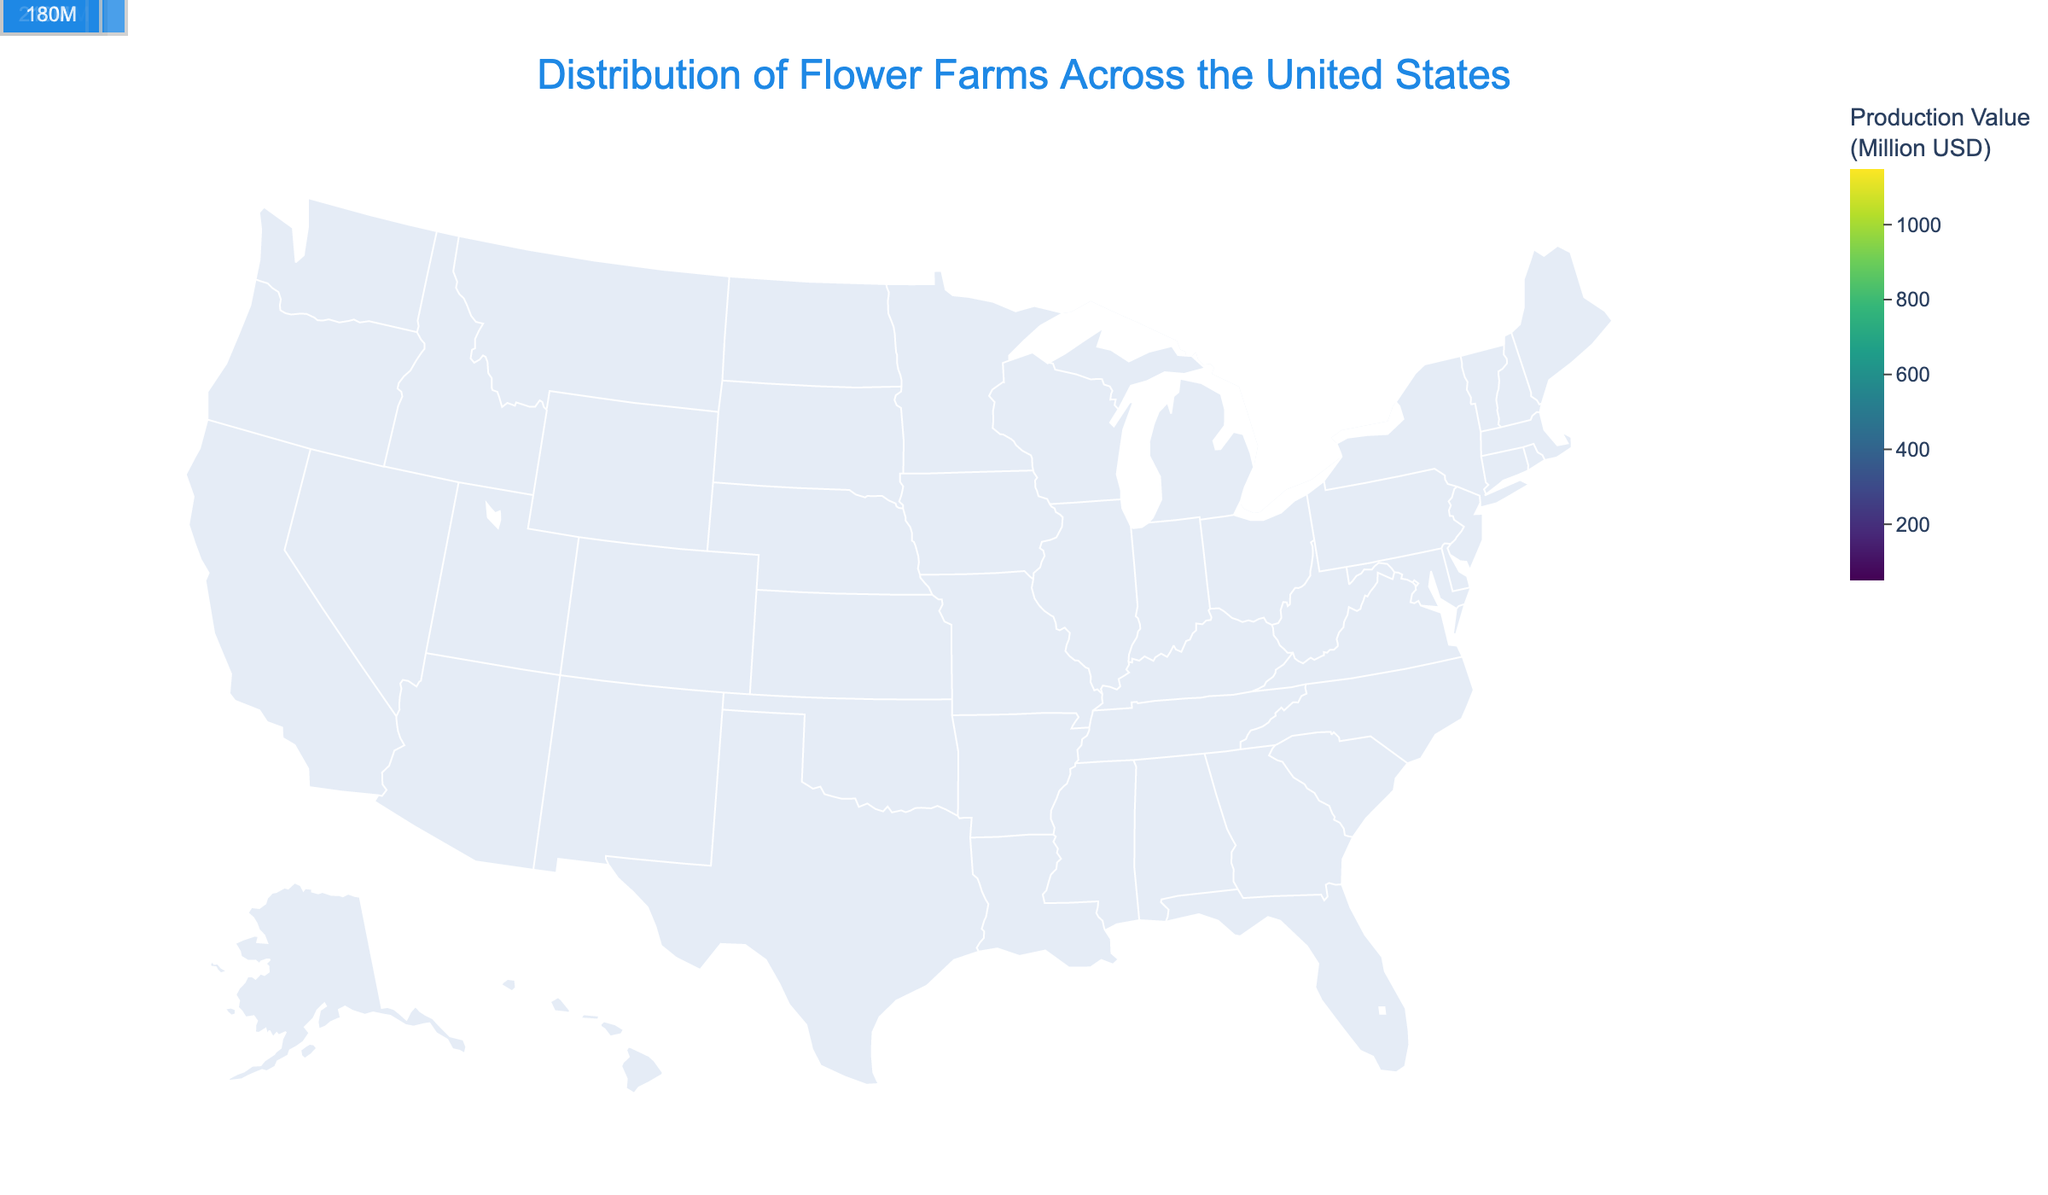How many states are shown in the figure? Count the number of states listed in the data
Answer: 15 Which state has the highest flower production value? Look for the state with the highest production value in the color scale and corresponding annotations
Answer: California What is the title of the figure? Refer to the top of the figure for the title text
Answer: Distribution of Flower Farms Across the United States Which region has the most number of flower farms? Sum the number of farms for each region and compare
Answer: West How many flower farms are there in Florida? Find Florida in the chart and check the hover data or annotation
Answer: 650 Which state in the Midwest has the smallest flower production value? Compare production values for Midwest states and identify the smallest one
Answer: Wisconsin What is the total production value of flower farms for the Northeast region? Sum the production value of New York, Pennsylvania, and New Jersey
Answer: 150 + 110 + 70 = 330 Which production region has more states: Southeast or Midwest? Count the number of states listed for Southeast and Midwest regions and compare
Answer: Midwest Is there any state from the Southwest region with its flower farm production value annotated in the figure? Check if there’s any annotation for a Southwest state
Answer: No Are there any lakes shown on the map? Look at the figure to see if lakes are visually represented
Answer: Yes 